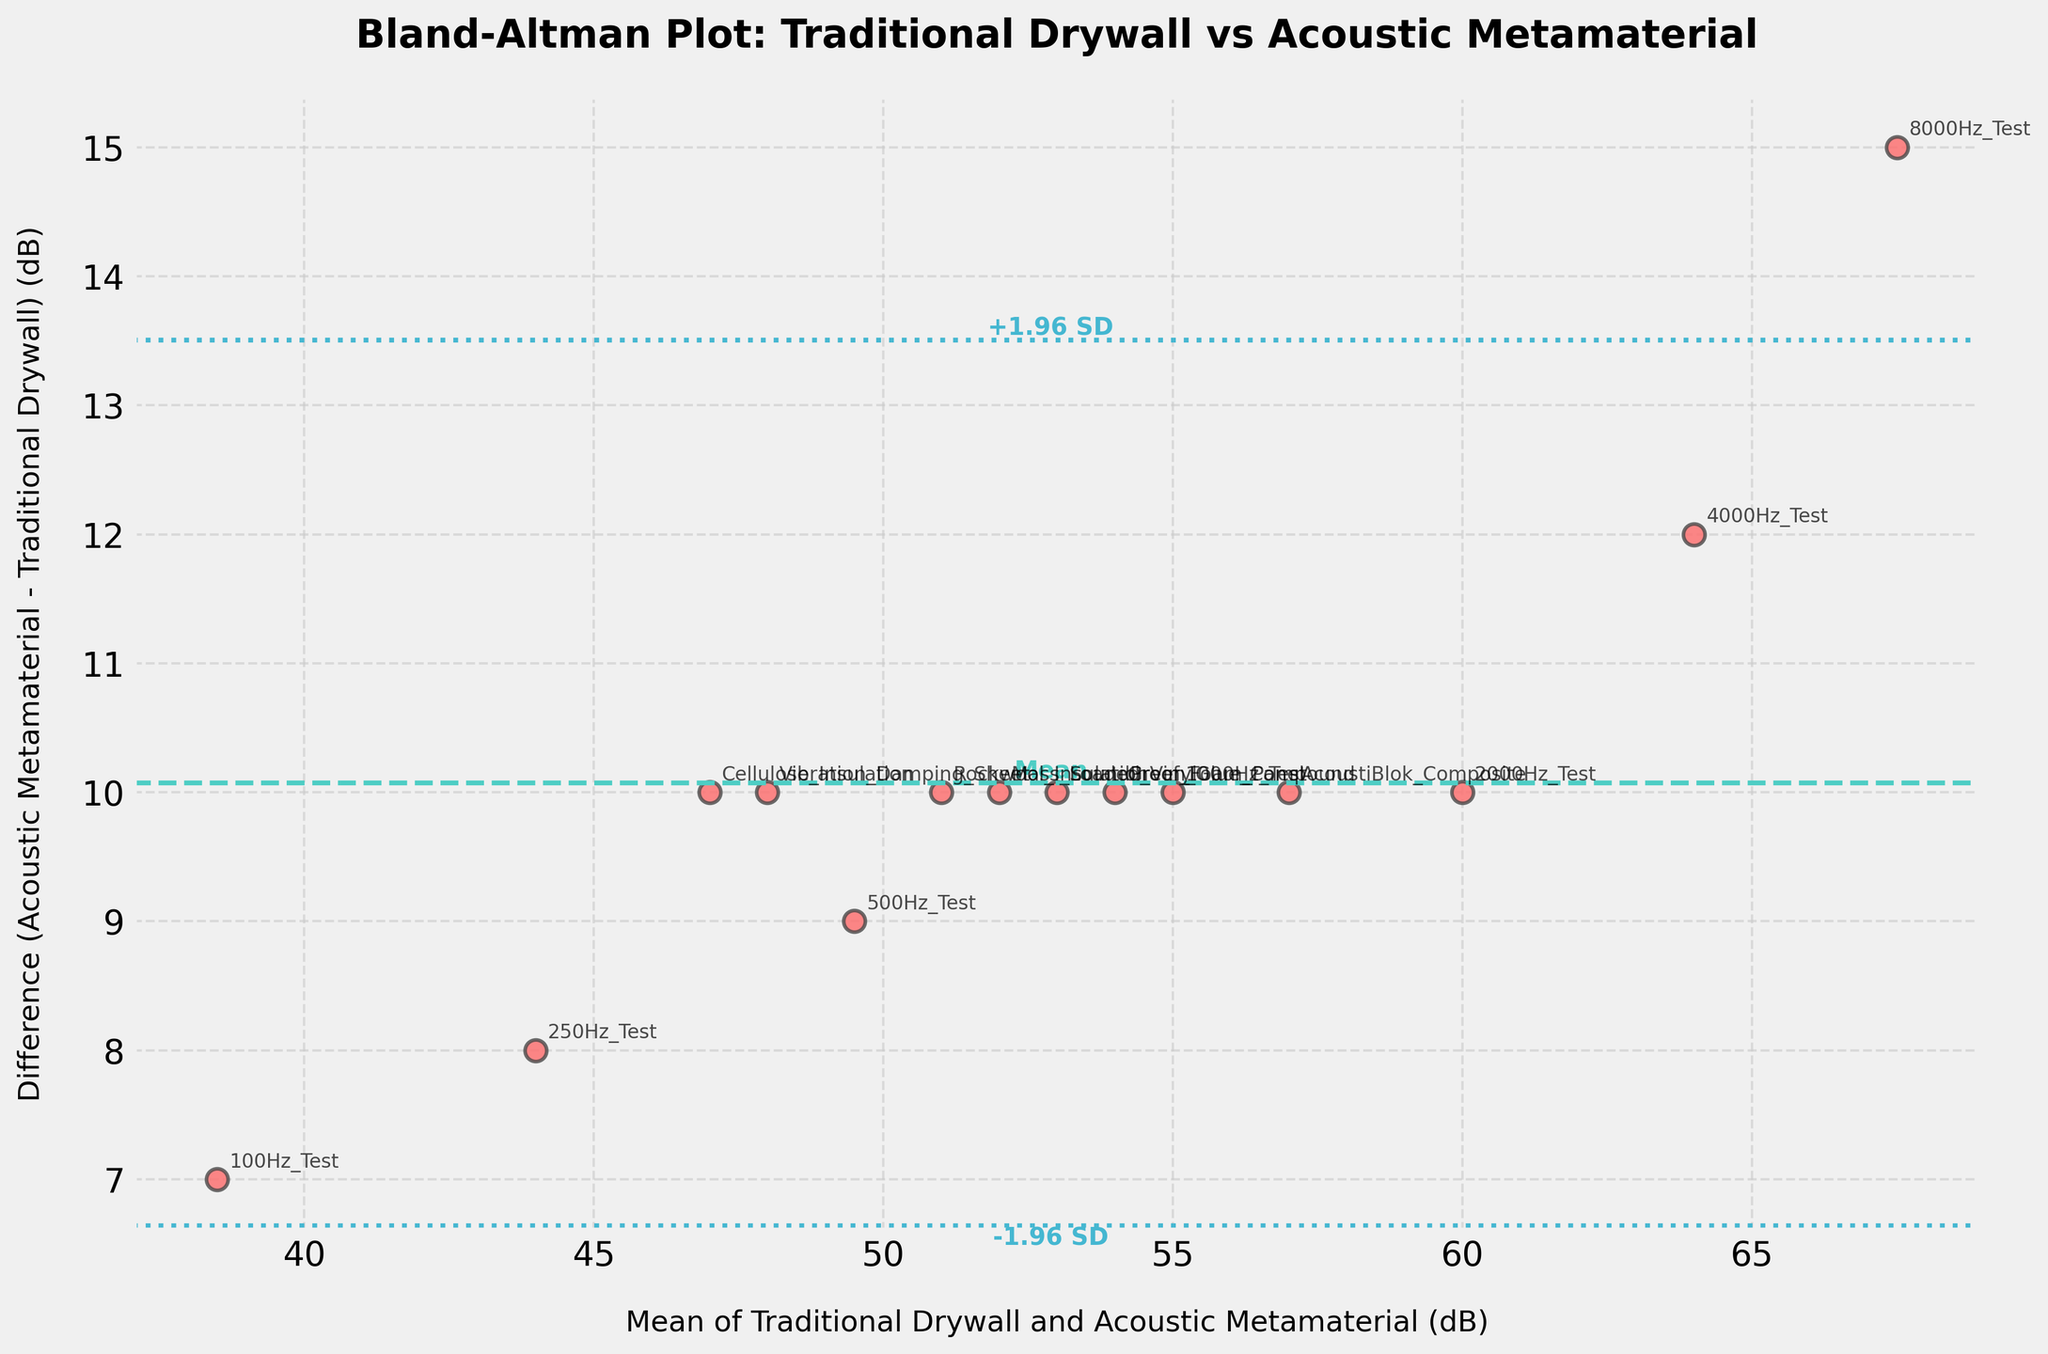What is the title of the plot? The title is clearly shown at the top of the plot, indicating the focus of the comparison.
Answer: Bland-Altman Plot: Traditional Drywall vs Acoustic Metamaterial What do the x-axis and y-axis represent? The x-axis represents the mean of the sound insulation values (in dB) for the traditional drywall and the acoustic metamaterial, while the y-axis represents the difference between these values (Acoustic Metamaterial - Traditional Drywall in dB). This information can be gathered by reading the axis labels.
Answer: The x-axis represents the mean (dB), and the y-axis represents the difference (dB) What do the horizontal dashed and dotted lines represent? The horizontal dashed line represents the mean difference between the traditional drywall and the acoustic metamaterial sound insulation values. The horizontal dotted lines represent the limits of agreement, which are the mean difference ± 1.96 times the standard deviation of the differences. This is indicated by the visual representation of the lines and their labels.
Answer: The dashed line is the mean difference, and the dotted lines are the limits of agreement How many data points are plotted on the Bland-Altman plot? By counting the number of data points (scatter points) visible on the plot, you can determine the total number of measurements included in the analysis.
Answer: 14 Which material shows better sound insulation properties, traditional drywall or acoustic metamaterial? By observing the y-axis, where differences are mainly positive, it is evident that acoustic metamaterial provides better sound insulation than traditional drywall. Positive differences indicate higher sound insulation values for the acoustic metamaterial.
Answer: Acoustic metamaterial What is the value of the mean difference (md) between the traditional drywall and the acoustic metamaterial? The mean difference is indicated by the horizontal dashed line labeled "Mean" on the y-axis.
Answer: Approximately 10 dB What is the approximate value of the upper limit of agreement? The upper limit of agreement is indicated by the upper dotted line labeled "+1.96 SD." This can be observed directly from the plot by reading the corresponding y-axis value.
Answer: Approximately 18 dB Which method has the highest mean sound insulation value, and what is that value? By locating all the data points on the plot, identify the one with the highest x-axis value (mean of the sound insulation values). This point corresponds to the method with the highest mean sound insulation.
Answer: 8000Hz_Test, 67.5 dB What is the range of the mean sound insulation values on the x-axis? The range can be determined by observing the minimum and maximum x-axis values where data points are plotted. This would give insight into the distribution of the mean sound insulation values.
Answer: Approximately 38.5 dB to 67.5 dB What does it imply if a data point lies above the upper limit of agreement or below the lower limit of agreement? If a point lies above the upper limit or below the lower limit, it suggests that the difference between the sound insulation values of the traditional drywall and the acoustic metamaterial for that particular method is unusually high or low. This indicates that the agreement between the two methods for that data point is outside the expected range, suggesting a potential outlier or inconsistency.
Answer: Indicate an outlier or inconsistency 